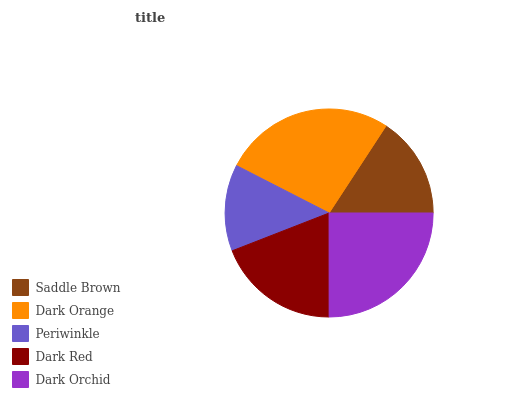Is Periwinkle the minimum?
Answer yes or no. Yes. Is Dark Orange the maximum?
Answer yes or no. Yes. Is Dark Orange the minimum?
Answer yes or no. No. Is Periwinkle the maximum?
Answer yes or no. No. Is Dark Orange greater than Periwinkle?
Answer yes or no. Yes. Is Periwinkle less than Dark Orange?
Answer yes or no. Yes. Is Periwinkle greater than Dark Orange?
Answer yes or no. No. Is Dark Orange less than Periwinkle?
Answer yes or no. No. Is Dark Red the high median?
Answer yes or no. Yes. Is Dark Red the low median?
Answer yes or no. Yes. Is Saddle Brown the high median?
Answer yes or no. No. Is Periwinkle the low median?
Answer yes or no. No. 